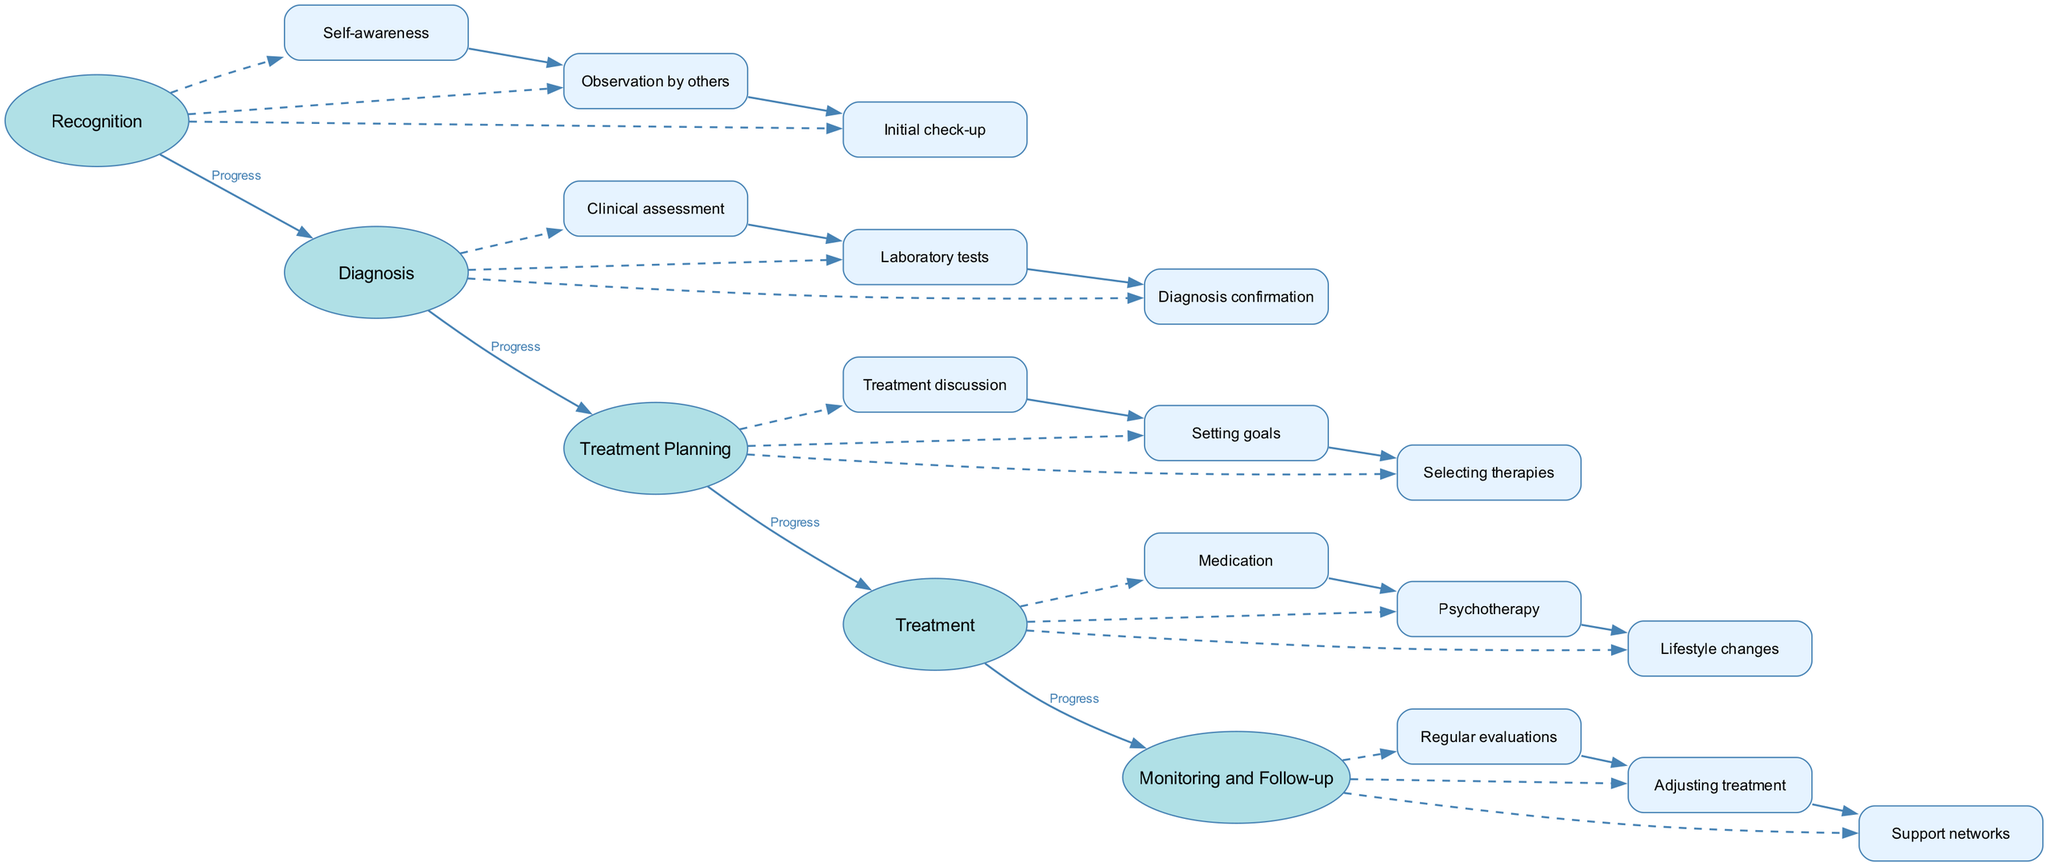What is the first stage in the depression treatment journey? The first stage listed in the diagram is "Recognition." It is the initial phase where symptoms of depression are identified.
Answer: Recognition How many steps are there in the "Diagnosis" stage? The "Diagnosis" stage contains three steps: Clinical assessment, Laboratory tests, and Diagnosis confirmation. This can be counted directly from the diagram's nodes.
Answer: 3 What connects the "Self-awareness" step to the "Initial check-up"? Both steps are part of the same stage "Recognition," and "Self-awareness" connects to "Observation by others" and then to "Initial check-up" sequentially through dashed edges.
Answer: Observation by others What is the purpose of the "Monitoring and Follow-up" stage? The "Monitoring and Follow-up" stage serves to ensure regular check-ins and make adjustments to treatment based on progress, as indicated by its description.
Answer: Regular check-ins and adjustments Which step follows "Setting goals" in the "Treatment Planning" stage? The step that directly follows "Setting goals" within the "Treatment Planning" stage is "Selecting therapies," according to the internal connections of the diagram.
Answer: Selecting therapies How does "Psychotherapy" relate to the "Treatment Planning" stage? "Psychotherapy" is part of a later stage, "Treatment," and it follows the detailed step-by-step plans created during the "Treatment Planning" stage. The relationship indicates it is an implementation of previously planned strategies.
Answer: Implementation of strategies What are the components included in the "Lifestyle changes" step? The "Lifestyle changes" step encompasses exercise, diet, and sleep improvements, which are aimed at supporting recovery in the treatment design.
Answer: Exercise, diet, sleep improvements What connects the final stage to the previous stages? The "Monitoring and Follow-up" stage connects to the "Treatment" stage with the label "Progress," which implies a flow of treatment progression leading up to this follow-up phase.
Answer: Progress What is required for "Diagnosis confirmation"? "Diagnosis confirmation" requires findings from clinical assessments and laboratory tests to validate the depression diagnosis accurately. This is detailed in the diagram's description of this step.
Answer: Findings from assessments and tests 